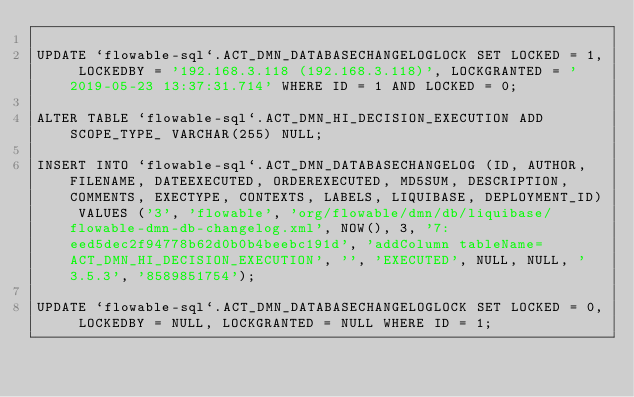Convert code to text. <code><loc_0><loc_0><loc_500><loc_500><_SQL_>
UPDATE `flowable-sql`.ACT_DMN_DATABASECHANGELOGLOCK SET LOCKED = 1, LOCKEDBY = '192.168.3.118 (192.168.3.118)', LOCKGRANTED = '2019-05-23 13:37:31.714' WHERE ID = 1 AND LOCKED = 0;

ALTER TABLE `flowable-sql`.ACT_DMN_HI_DECISION_EXECUTION ADD SCOPE_TYPE_ VARCHAR(255) NULL;

INSERT INTO `flowable-sql`.ACT_DMN_DATABASECHANGELOG (ID, AUTHOR, FILENAME, DATEEXECUTED, ORDEREXECUTED, MD5SUM, DESCRIPTION, COMMENTS, EXECTYPE, CONTEXTS, LABELS, LIQUIBASE, DEPLOYMENT_ID) VALUES ('3', 'flowable', 'org/flowable/dmn/db/liquibase/flowable-dmn-db-changelog.xml', NOW(), 3, '7:eed5dec2f94778b62d0b0b4beebc191d', 'addColumn tableName=ACT_DMN_HI_DECISION_EXECUTION', '', 'EXECUTED', NULL, NULL, '3.5.3', '8589851754');

UPDATE `flowable-sql`.ACT_DMN_DATABASECHANGELOGLOCK SET LOCKED = 0, LOCKEDBY = NULL, LOCKGRANTED = NULL WHERE ID = 1;

</code> 